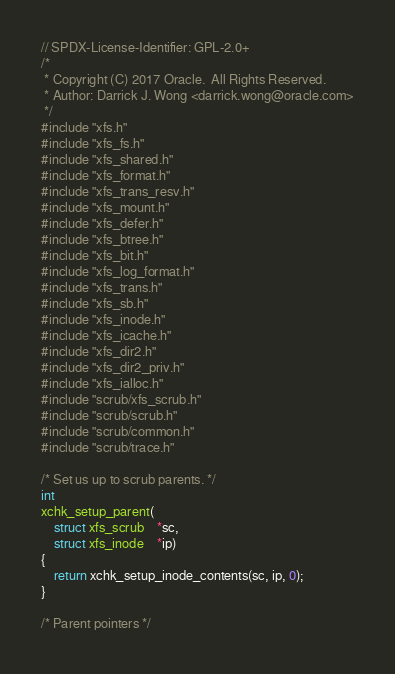Convert code to text. <code><loc_0><loc_0><loc_500><loc_500><_C_>// SPDX-License-Identifier: GPL-2.0+
/*
 * Copyright (C) 2017 Oracle.  All Rights Reserved.
 * Author: Darrick J. Wong <darrick.wong@oracle.com>
 */
#include "xfs.h"
#include "xfs_fs.h"
#include "xfs_shared.h"
#include "xfs_format.h"
#include "xfs_trans_resv.h"
#include "xfs_mount.h"
#include "xfs_defer.h"
#include "xfs_btree.h"
#include "xfs_bit.h"
#include "xfs_log_format.h"
#include "xfs_trans.h"
#include "xfs_sb.h"
#include "xfs_inode.h"
#include "xfs_icache.h"
#include "xfs_dir2.h"
#include "xfs_dir2_priv.h"
#include "xfs_ialloc.h"
#include "scrub/xfs_scrub.h"
#include "scrub/scrub.h"
#include "scrub/common.h"
#include "scrub/trace.h"

/* Set us up to scrub parents. */
int
xchk_setup_parent(
	struct xfs_scrub	*sc,
	struct xfs_inode	*ip)
{
	return xchk_setup_inode_contents(sc, ip, 0);
}

/* Parent pointers */
</code> 